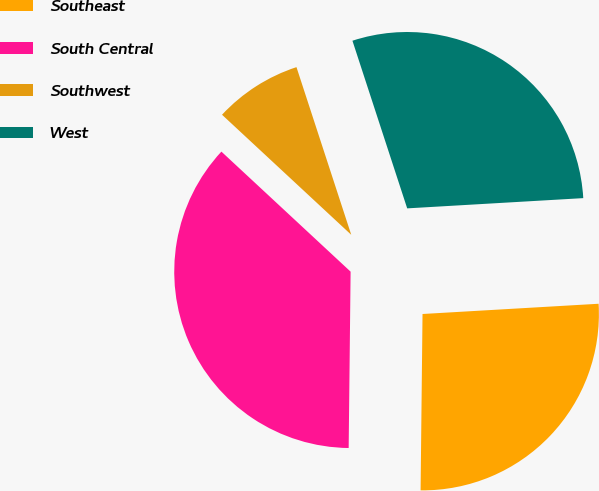Convert chart to OTSL. <chart><loc_0><loc_0><loc_500><loc_500><pie_chart><fcel>Southeast<fcel>South Central<fcel>Southwest<fcel>West<nl><fcel>26.1%<fcel>36.74%<fcel>8.06%<fcel>29.1%<nl></chart> 